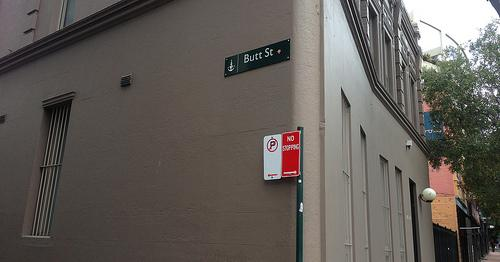Enumerate the visible security measures on the building exteriors. There are bars covering windows and black metal fences present in the image. Explain the purpose of the various signs present in the image. The signs indicate street names, parking restrictions, and stopping regulations, providing guidance and information to the public. In a sentence, describe the most noticeable feature of the signs in the image. The black and white "Butt St" sign with white letters, and the red and white "no stopping" sign are the most noticeable features. Briefly explain the significance of the tree in the image. The tree adds a touch of nature to the urban scene, and its green leaves create a pleasant contrast with the surrounding man-made structures. What does the image seem to mainly focus on, and what does it convey about the location? The image mainly focuses on the urban scene with various buildings and signs, suggesting that it is a densely populated area with traffic and parking regulations. Describe the types and colors of signs present in the image. There are green street signs, black and white Butt St signs, and a red and white no stopping sign. Identify the different shapes and designs of the windows in the image. There are windows with bars, brick windows on the second floor, and tan barred windows, all with different shapes and designs. Mention the most prominent building color in the image and give a brief description of its features. The most prominent building color is grey, and it has an exterior facade, several windows, and a door. Describe the overall mood and atmosphere of the image. The image has a busy and urban atmosphere, with various buildings, signs, and a touch of nature from the green tree leaves. Summarize the different architectural elements present in the image. There are grey, orange, and beige buildings, with various window styles, doors, fences, a white round outside lamp, and bars on windows. 